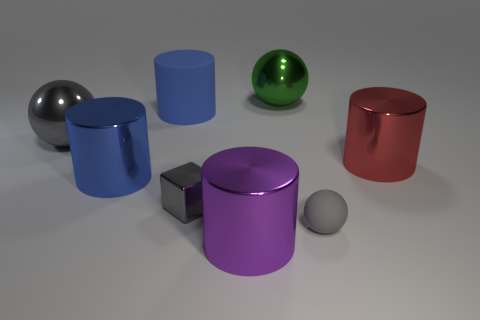There is a block; is its color the same as the matte thing that is in front of the gray metallic sphere?
Your answer should be very brief. Yes. What shape is the big object that is the same color as the small sphere?
Provide a succinct answer. Sphere. The large gray shiny object is what shape?
Your answer should be compact. Sphere. Do the tiny metal block and the small rubber object have the same color?
Your answer should be very brief. Yes. What number of things are large things to the right of the big green thing or gray balls?
Offer a very short reply. 3. What size is the gray sphere that is made of the same material as the red cylinder?
Offer a very short reply. Large. Is the number of matte objects in front of the small gray block greater than the number of tiny cylinders?
Keep it short and to the point. Yes. There is a green shiny thing; does it have the same shape as the gray metallic object in front of the big red cylinder?
Provide a succinct answer. No. How many large objects are either red cylinders or gray metal objects?
Your response must be concise. 2. There is a ball that is the same color as the small matte thing; what size is it?
Your answer should be very brief. Large. 